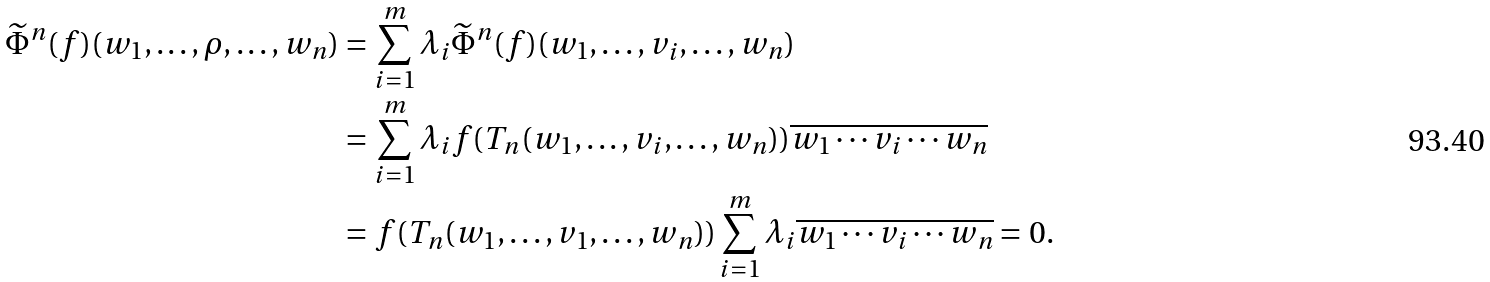<formula> <loc_0><loc_0><loc_500><loc_500>\widetilde { \Phi } ^ { n } ( f ) ( w _ { 1 } , \dots , \rho , \dots , w _ { n } ) & = \sum _ { i = 1 } ^ { m } \lambda _ { i } \widetilde { \Phi } ^ { n } ( f ) ( w _ { 1 } , \dots , v _ { i } , \dots , w _ { n } ) \\ & = \sum _ { i = 1 } ^ { m } \lambda _ { i } f ( T _ { n } ( w _ { 1 } , \dots , v _ { i } , \dots , w _ { n } ) ) \overline { w _ { 1 } \cdots v _ { i } \cdots w _ { n } } \\ & = f ( T _ { n } ( w _ { 1 } , \dots , v _ { 1 } , \dots , w _ { n } ) ) \sum _ { i = 1 } ^ { m } \lambda _ { i } \overline { w _ { 1 } \cdots v _ { i } \cdots w _ { n } } = 0 .</formula> 